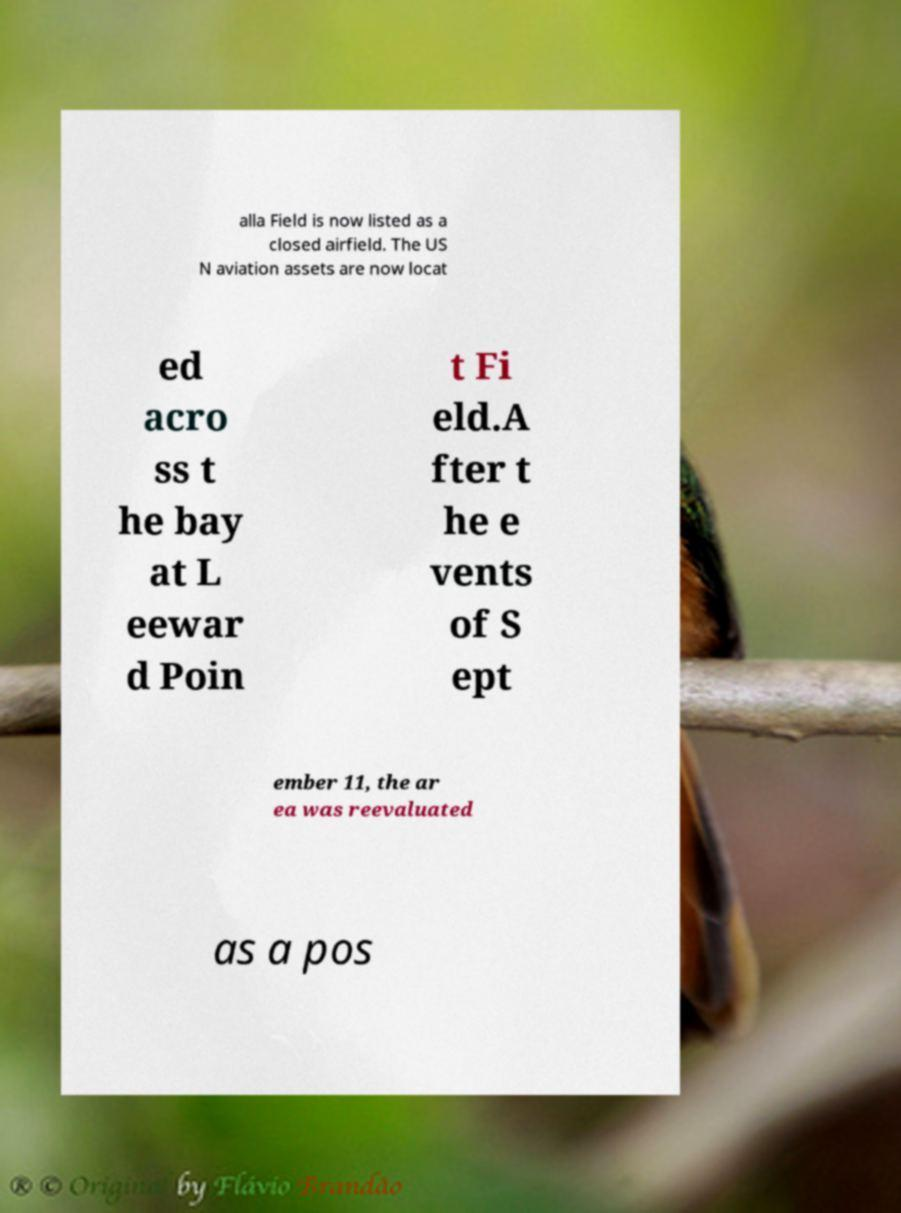Can you accurately transcribe the text from the provided image for me? alla Field is now listed as a closed airfield. The US N aviation assets are now locat ed acro ss t he bay at L eewar d Poin t Fi eld.A fter t he e vents of S ept ember 11, the ar ea was reevaluated as a pos 